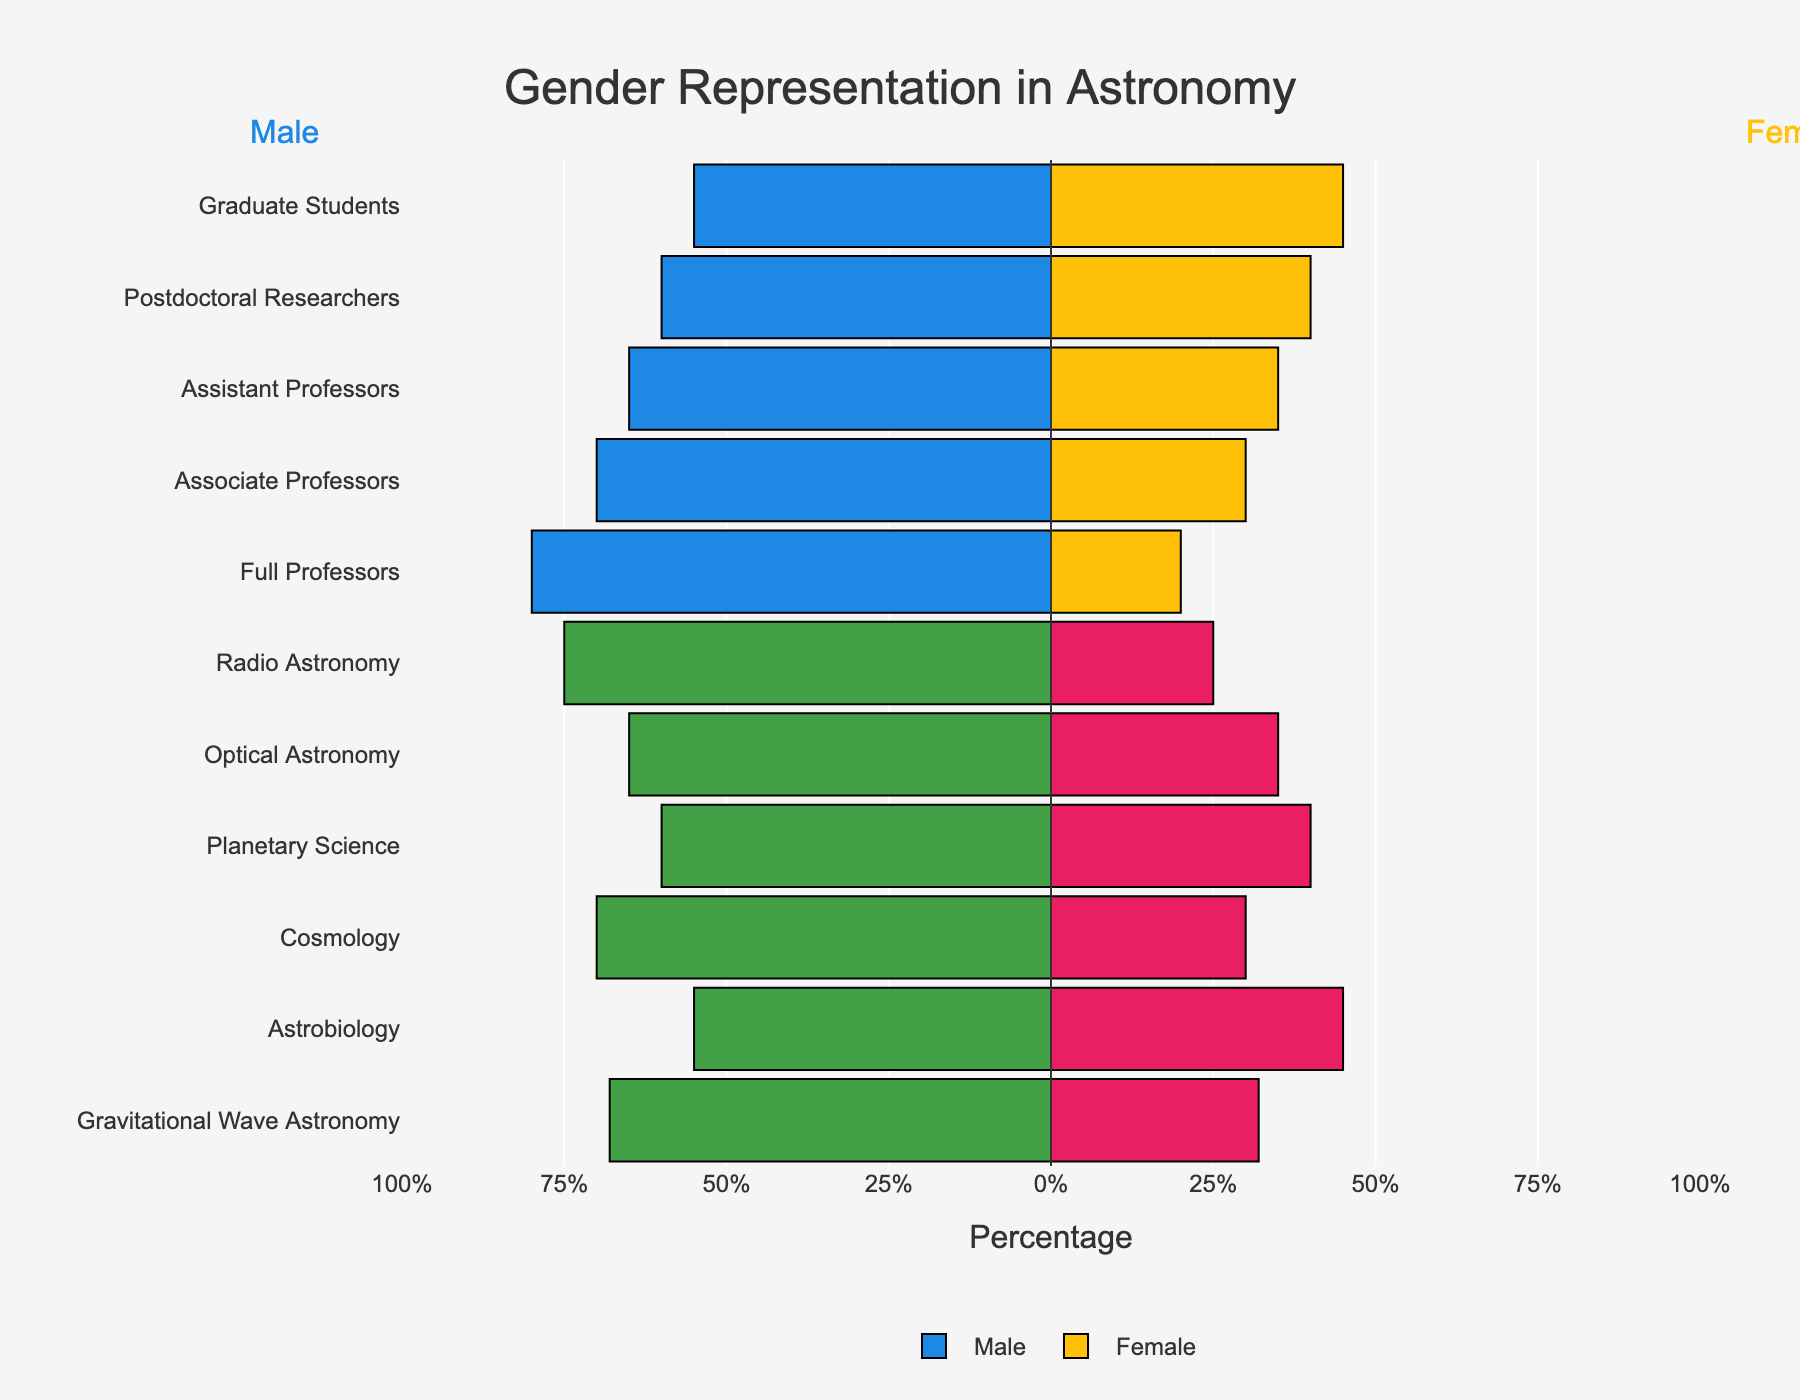How many career stages are represented in the figure? The figure shows different levels of career stages, and one can count the distinct career stages listed on the y-axis.
Answer: 5 Which subfield has the highest representation of males? The figure presents bars for various subfields. By visually comparing the lengths of the bars corresponding to male representation, one can identify the subfield with the longest bar.
Answer: Radio Astronomy Is the difference in female representation greater between Graduate Students and Full Professors or between Postdoctoral Researchers and Associate Professors? Compare the percentages for females in Graduate Students (45%) and Full Professors (20%) to get a difference of 25%. Similarly, compare the percentages for females in Postdoctoral Researchers (40%) and Associate Professors (30%) to get a difference of 10%.
Answer: Graduate Students and Full Professors Which subfield has the most balanced gender representation? Look for the subfield where the male and female bars are closest in length.
Answer: Astrobiology What is the gender representation difference for Assistant Professors? For Assistant Professors, males represent 65%, and females represent 35%, leading to a difference of 30%.
Answer: 30% Between which career stages is the increase in male representation the smallest? Compare the differences in male representation between consecutive career stages: (55%-Graduate Students to 60%-Postdoctoral Researchers, 60%-Postdoctoral Researchers to 65%-Assistant Professors, etc.). The smallest increase is between Graduate Students and Postdoctoral Researchers.
Answer: Graduate Students and Postdoctoral Researchers By how much does female representation decrease from Graduate Students to Full Professors? Female representation is 45% in Graduate Students and 20% in Full Professors. The decrease is 45% - 20% = 25%.
Answer: 25% Which career stage has the largest gender gap and what is the value of that gap? The career stage with the largest gender gap can be identified by the greatest difference between male and female representation bars.
Answer: Full Professors, 60% Does Cosmology have more female representation than Optical Astronomy? Compare the female representation bars for Cosmology (30%) and Optical Astronomy (35%). Cosmology has less female representation.
Answer: No 